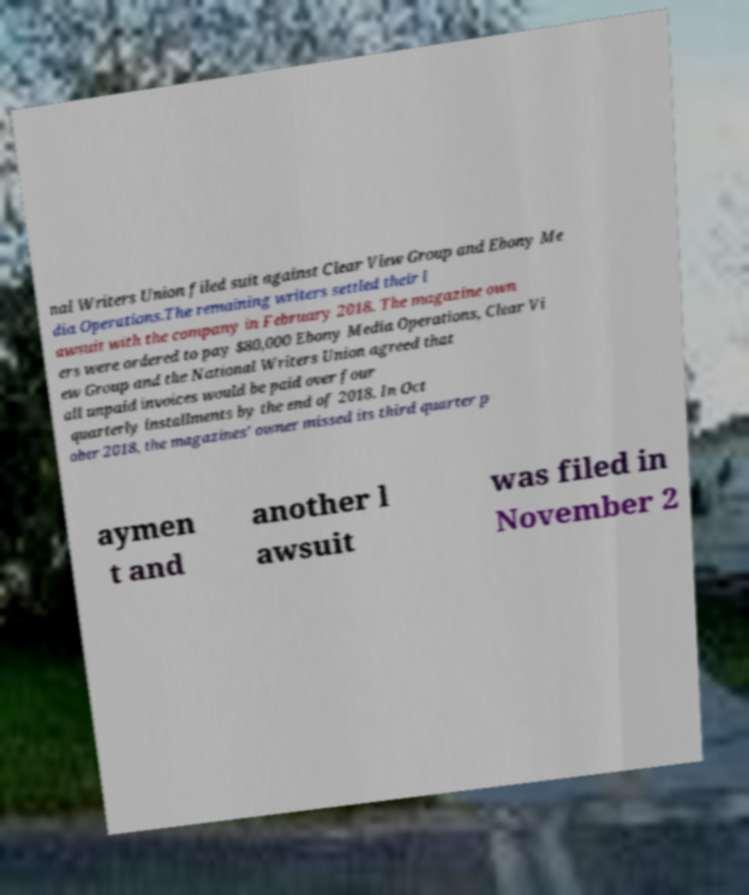I need the written content from this picture converted into text. Can you do that? nal Writers Union filed suit against Clear View Group and Ebony Me dia Operations.The remaining writers settled their l awsuit with the company in February 2018. The magazine own ers were ordered to pay $80,000 Ebony Media Operations, Clear Vi ew Group and the National Writers Union agreed that all unpaid invoices would be paid over four quarterly installments by the end of 2018. In Oct ober 2018, the magazines' owner missed its third quarter p aymen t and another l awsuit was filed in November 2 